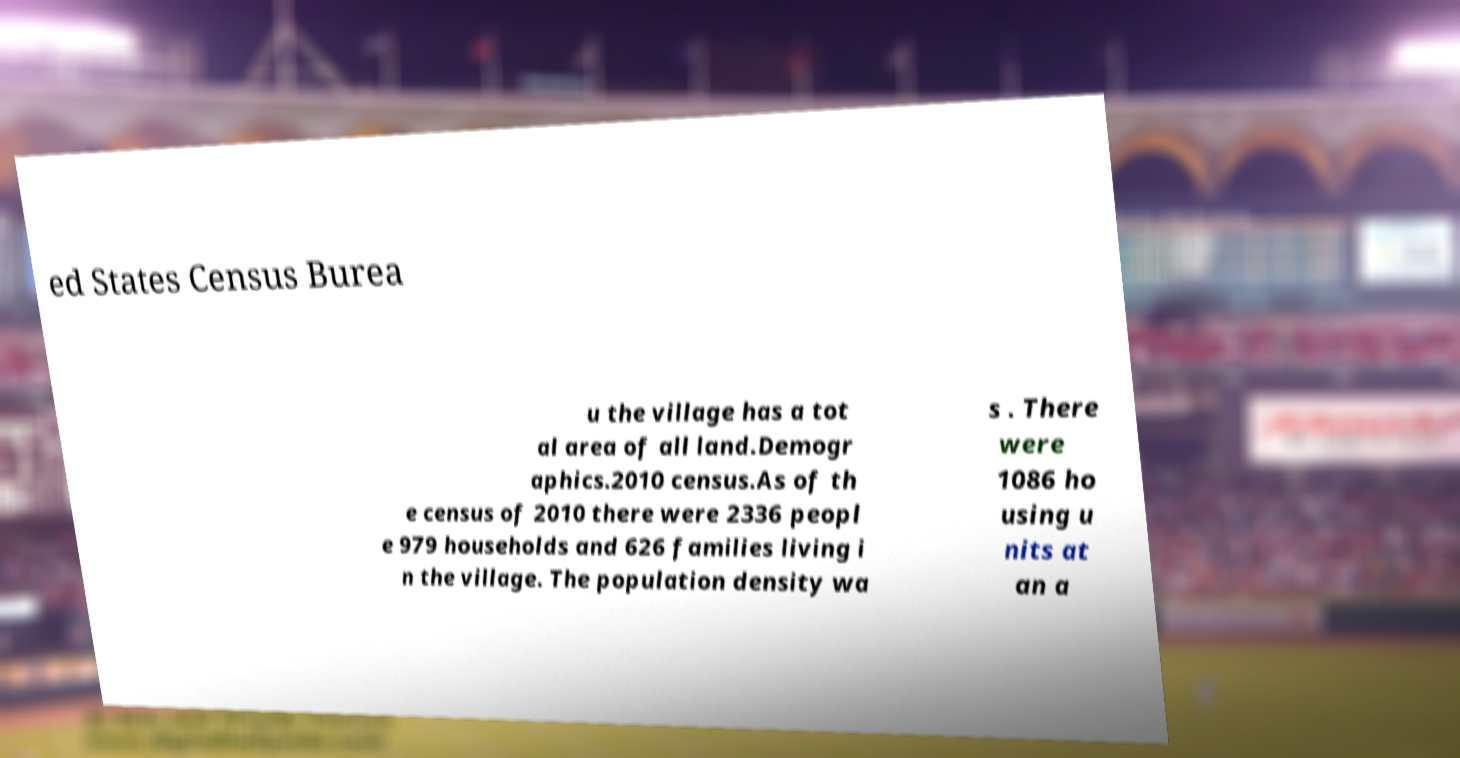There's text embedded in this image that I need extracted. Can you transcribe it verbatim? ed States Census Burea u the village has a tot al area of all land.Demogr aphics.2010 census.As of th e census of 2010 there were 2336 peopl e 979 households and 626 families living i n the village. The population density wa s . There were 1086 ho using u nits at an a 